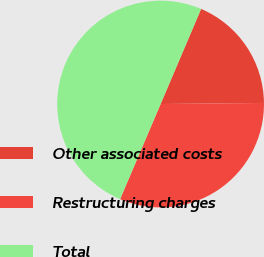Convert chart. <chart><loc_0><loc_0><loc_500><loc_500><pie_chart><fcel>Other associated costs<fcel>Restructuring charges<fcel>Total<nl><fcel>18.42%<fcel>31.58%<fcel>50.0%<nl></chart> 